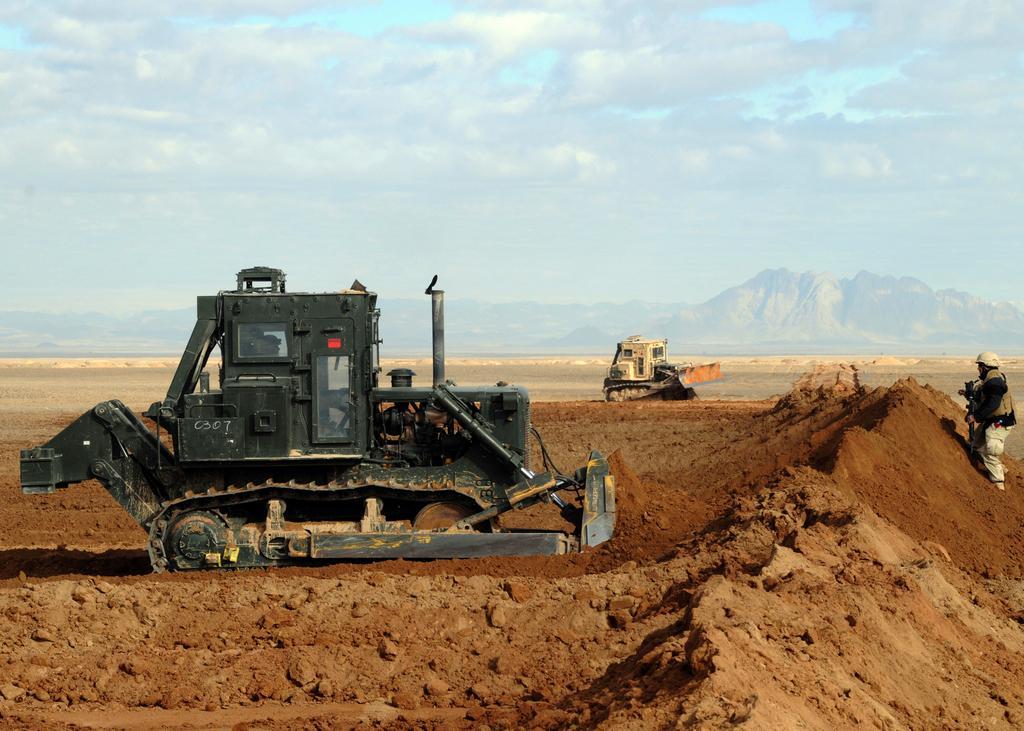Please provide a concise description of this image. In this picture we can see there are two bulldozers and on the right side of the bulldozers there is a person. Behind the bulldozers there are hills and a cloudy sky. 